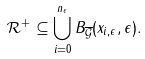<formula> <loc_0><loc_0><loc_500><loc_500>{ \mathcal { R } } ^ { + } \subseteq \bigcup _ { i = 0 } ^ { n _ { \epsilon } } B _ { \overline { \mathcal { G } } } ( x _ { i , \epsilon } , \epsilon ) .</formula> 